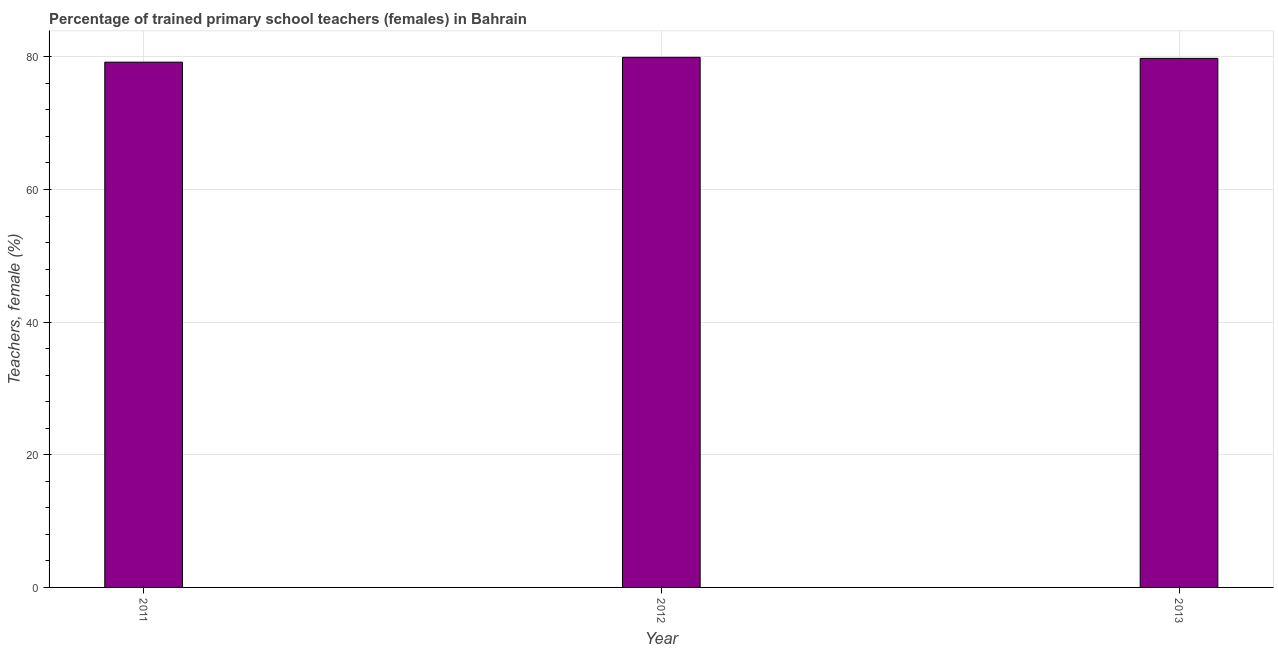What is the title of the graph?
Keep it short and to the point. Percentage of trained primary school teachers (females) in Bahrain. What is the label or title of the Y-axis?
Keep it short and to the point. Teachers, female (%). What is the percentage of trained female teachers in 2012?
Your response must be concise. 79.93. Across all years, what is the maximum percentage of trained female teachers?
Keep it short and to the point. 79.93. Across all years, what is the minimum percentage of trained female teachers?
Your response must be concise. 79.2. In which year was the percentage of trained female teachers maximum?
Offer a very short reply. 2012. In which year was the percentage of trained female teachers minimum?
Your response must be concise. 2011. What is the sum of the percentage of trained female teachers?
Ensure brevity in your answer.  238.91. What is the difference between the percentage of trained female teachers in 2011 and 2012?
Keep it short and to the point. -0.73. What is the average percentage of trained female teachers per year?
Ensure brevity in your answer.  79.64. What is the median percentage of trained female teachers?
Your response must be concise. 79.77. Is the difference between the percentage of trained female teachers in 2011 and 2013 greater than the difference between any two years?
Give a very brief answer. No. What is the difference between the highest and the second highest percentage of trained female teachers?
Your answer should be very brief. 0.16. What is the difference between the highest and the lowest percentage of trained female teachers?
Provide a short and direct response. 0.73. What is the difference between two consecutive major ticks on the Y-axis?
Make the answer very short. 20. What is the Teachers, female (%) in 2011?
Make the answer very short. 79.2. What is the Teachers, female (%) of 2012?
Make the answer very short. 79.93. What is the Teachers, female (%) in 2013?
Make the answer very short. 79.77. What is the difference between the Teachers, female (%) in 2011 and 2012?
Offer a very short reply. -0.73. What is the difference between the Teachers, female (%) in 2011 and 2013?
Offer a terse response. -0.57. What is the difference between the Teachers, female (%) in 2012 and 2013?
Your response must be concise. 0.16. What is the ratio of the Teachers, female (%) in 2011 to that in 2012?
Provide a succinct answer. 0.99. What is the ratio of the Teachers, female (%) in 2011 to that in 2013?
Keep it short and to the point. 0.99. What is the ratio of the Teachers, female (%) in 2012 to that in 2013?
Your answer should be very brief. 1. 